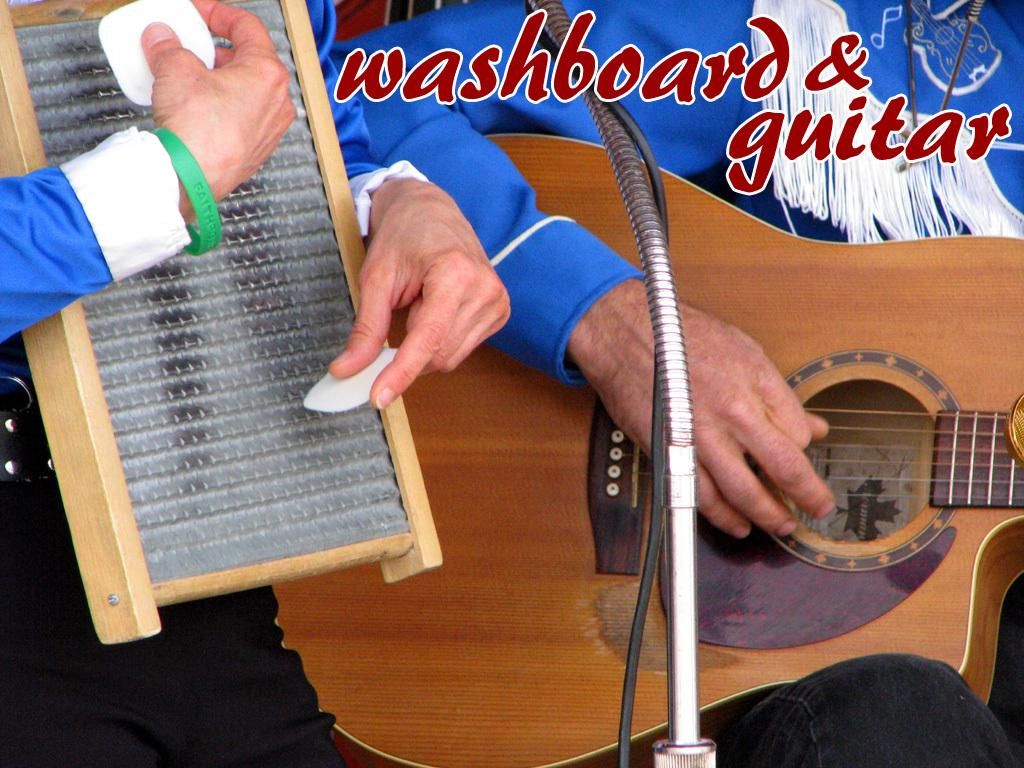What is the person in the image doing? The person is standing in the image and holding a guitar in his hand. Can you describe the other person in the image? There is another man in the image, and he is holding a musical instrument. What type of activity is taking place in the image? The image depicts a musical activity, as both individuals are holding musical instruments. What year is the wine bottle in the image from? There is no wine bottle present in the image. Is there a woman playing a musical instrument in the image? No, there are only two men present in the image, and both are holding musical instruments. 